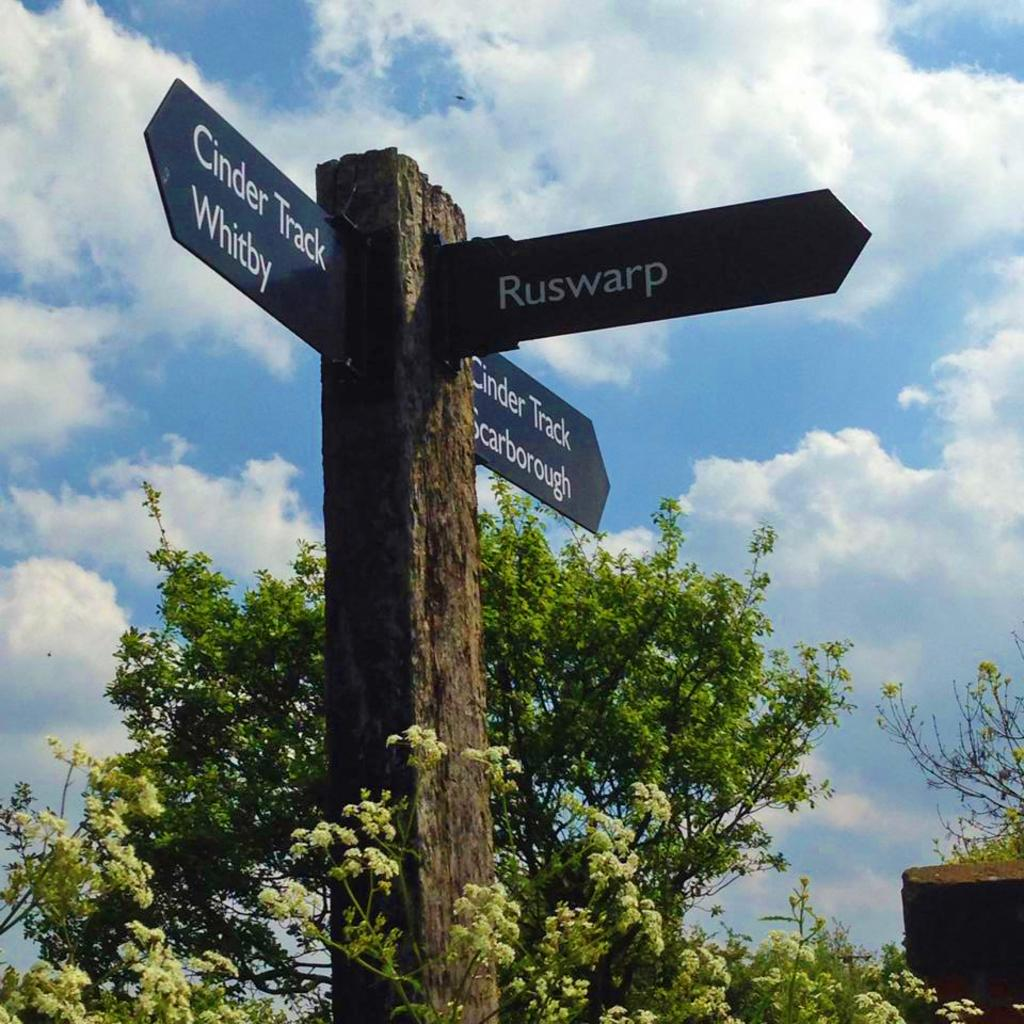What can be seen in the foreground of the image? There are three direction sign boards in the foreground of the image. What type of vegetation is present in the image? There is a plant and a tree in the image. Can you tell me how many deer are visible in the image? There are no deer present in the image. What type of soap is being used to water the plant in the image? There is no soap or watering activity depicted in the image; it only shows a plant and a tree. 